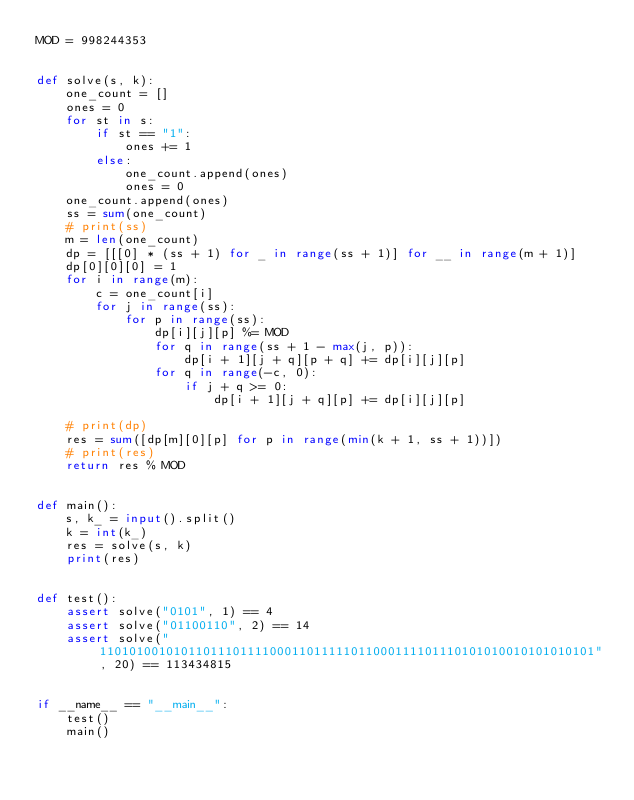<code> <loc_0><loc_0><loc_500><loc_500><_Python_>MOD = 998244353


def solve(s, k):
    one_count = []
    ones = 0
    for st in s:
        if st == "1":
            ones += 1
        else:
            one_count.append(ones)
            ones = 0
    one_count.append(ones)
    ss = sum(one_count)
    # print(ss)
    m = len(one_count)
    dp = [[[0] * (ss + 1) for _ in range(ss + 1)] for __ in range(m + 1)]
    dp[0][0][0] = 1
    for i in range(m):
        c = one_count[i]
        for j in range(ss):
            for p in range(ss):
                dp[i][j][p] %= MOD
                for q in range(ss + 1 - max(j, p)):
                    dp[i + 1][j + q][p + q] += dp[i][j][p]
                for q in range(-c, 0):
                    if j + q >= 0:
                        dp[i + 1][j + q][p] += dp[i][j][p]

    # print(dp)
    res = sum([dp[m][0][p] for p in range(min(k + 1, ss + 1))])
    # print(res)
    return res % MOD


def main():
    s, k_ = input().split()
    k = int(k_)
    res = solve(s, k)
    print(res)


def test():
    assert solve("0101", 1) == 4
    assert solve("01100110", 2) == 14
    assert solve("1101010010101101110111100011011111011000111101110101010010101010101", 20) == 113434815


if __name__ == "__main__":
    test()
    main()
</code> 